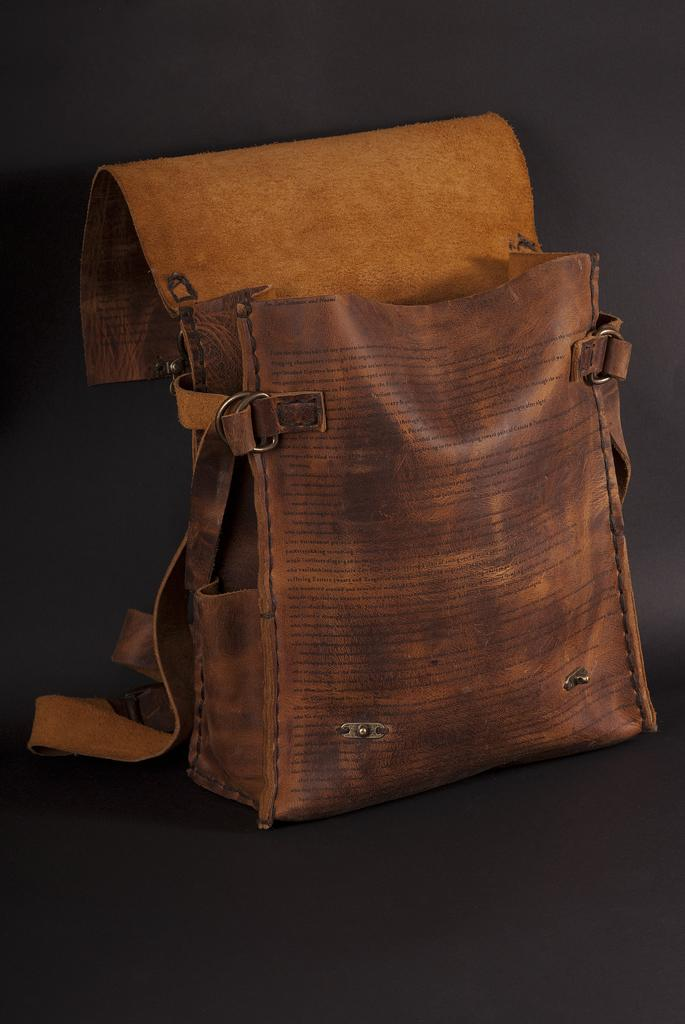What object can be seen in the image? There is a bag in the image. What type of stone is used to create the nation's flag in the image? There is no nation's flag or stone present in the image; it only features a bag. How many patches are visible on the bag in the image? There are no patches visible on the bag in the image. 